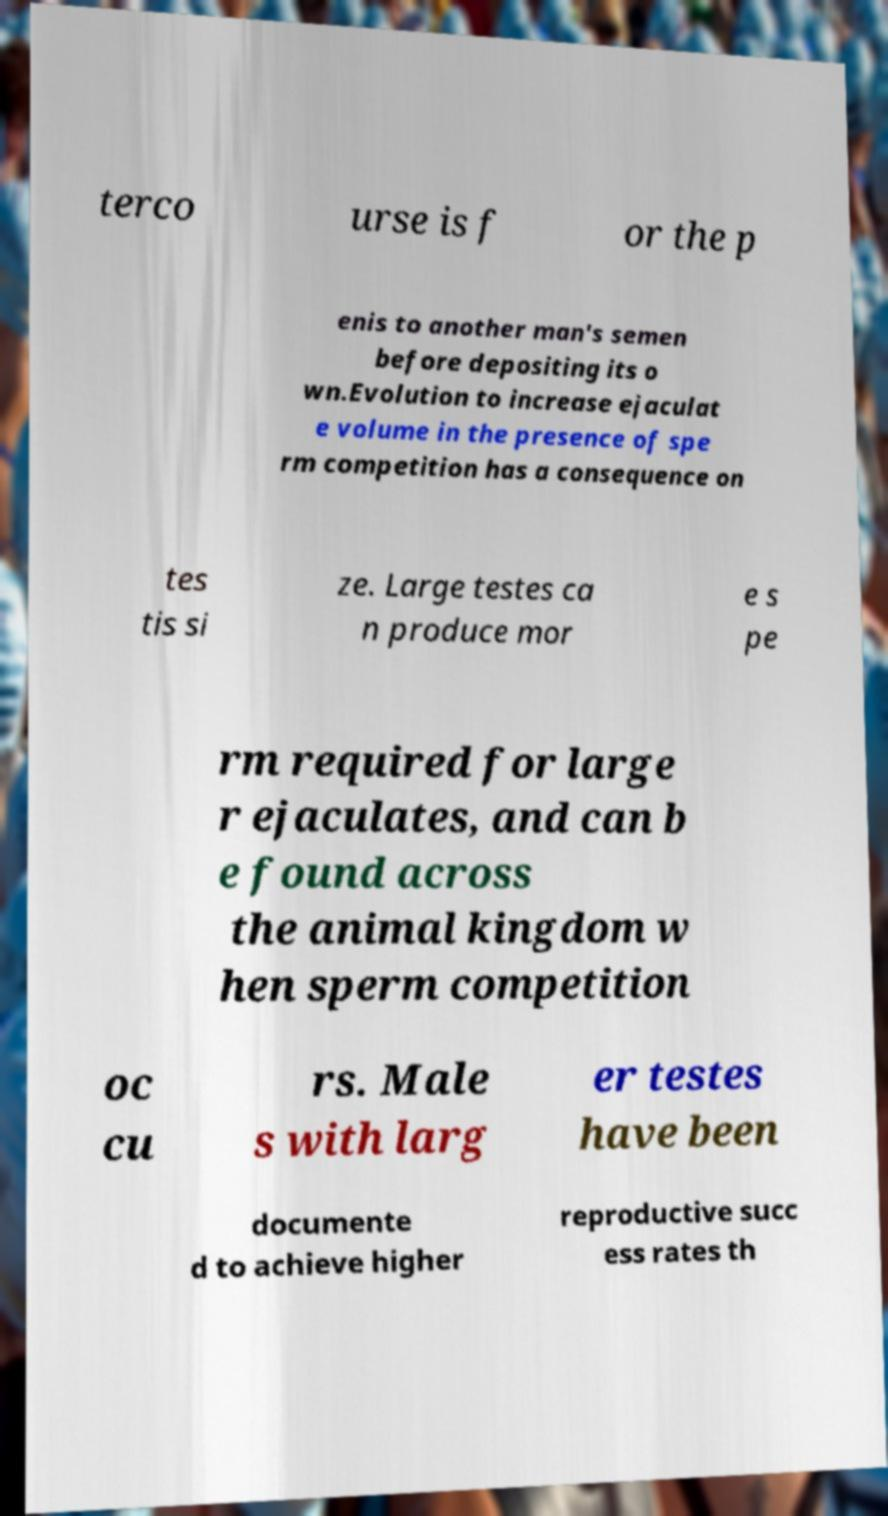There's text embedded in this image that I need extracted. Can you transcribe it verbatim? terco urse is f or the p enis to another man's semen before depositing its o wn.Evolution to increase ejaculat e volume in the presence of spe rm competition has a consequence on tes tis si ze. Large testes ca n produce mor e s pe rm required for large r ejaculates, and can b e found across the animal kingdom w hen sperm competition oc cu rs. Male s with larg er testes have been documente d to achieve higher reproductive succ ess rates th 